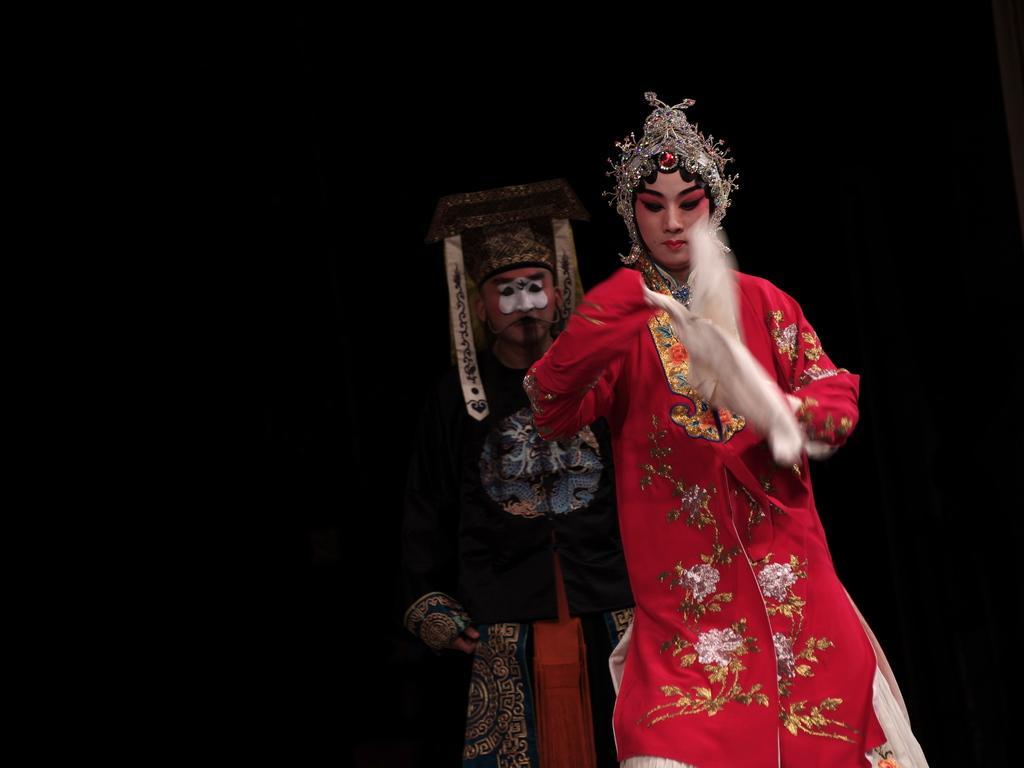Can you describe this image briefly? In this image I can see two persons wearing costumes and the black colored background. 